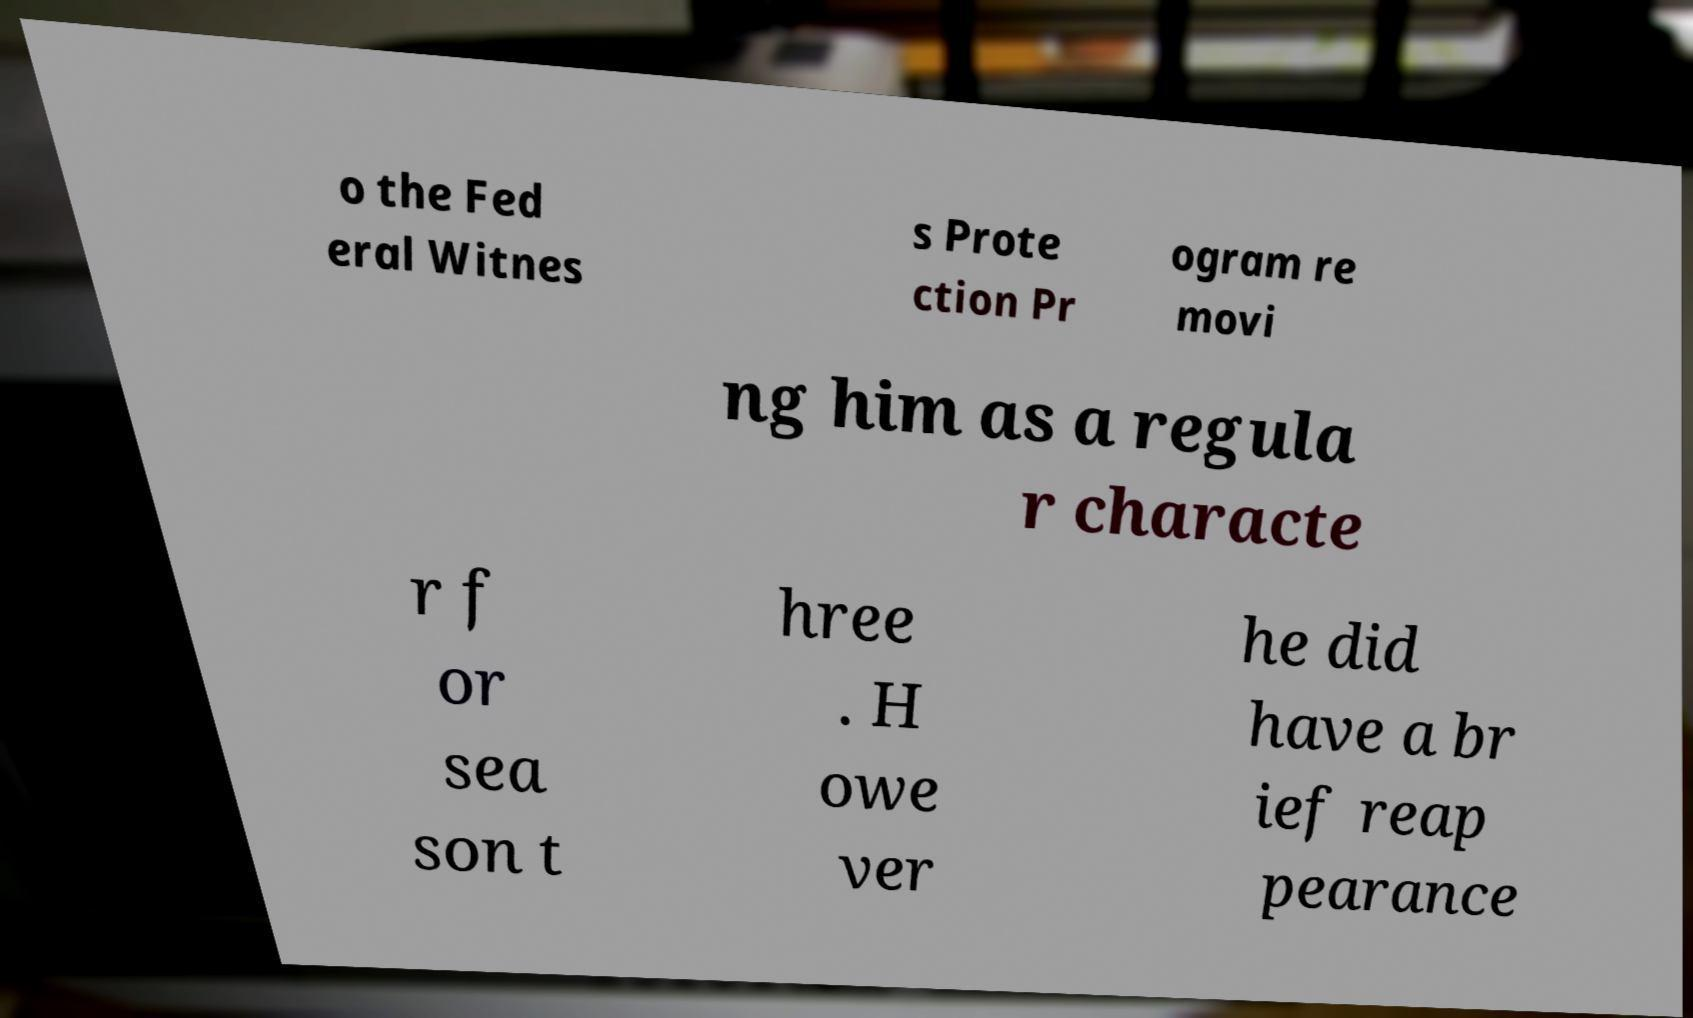For documentation purposes, I need the text within this image transcribed. Could you provide that? o the Fed eral Witnes s Prote ction Pr ogram re movi ng him as a regula r characte r f or sea son t hree . H owe ver he did have a br ief reap pearance 